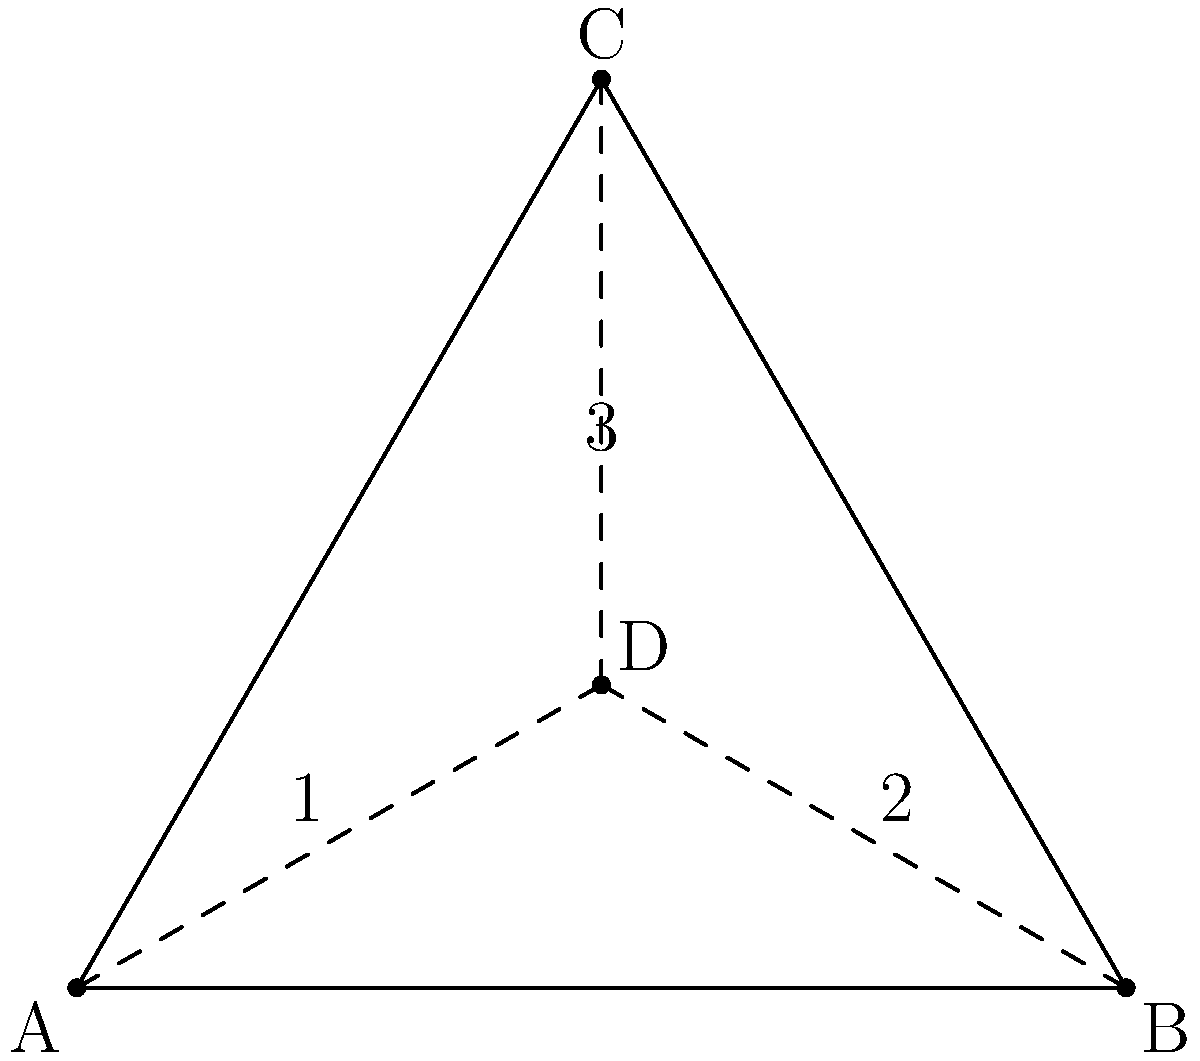In an Afrobeats dance formation, three dancers form an equilateral triangle ABC, with a fourth dancer at point D, the centroid of the triangle. The dance routine involves rotations around point D. How many unique positions can be achieved through 120° rotations around D while maintaining the formation's shape? To solve this problem, we need to consider the symmetry of the equilateral triangle and the rotations around its centroid:

1. The equilateral triangle has 3-fold rotational symmetry around its centroid (point D).

2. A 120° rotation is equivalent to a one-third turn of the entire formation.

3. We need to determine how many distinct configurations can be achieved through these rotations:

   a) Initial position (0° rotation)
   b) After one 120° rotation clockwise
   c) After two 120° rotations clockwise (equivalent to one 120° rotation counterclockwise)

4. The third 120° rotation clockwise (360° total) would return the formation to its initial position.

5. In each of these three positions, the overall shape of the formation remains the same, but the individual dancers occupy different positions relative to the starting configuration.

6. Therefore, there are 3 unique positions that can be achieved through 120° rotations while maintaining the formation's shape.

This concept is related to the cyclic group of order 3, denoted as $C_3$ or $\mathbb{Z}_3$ in group theory, which describes the symmetry of the equilateral triangle under 120° rotations.
Answer: 3 unique positions 